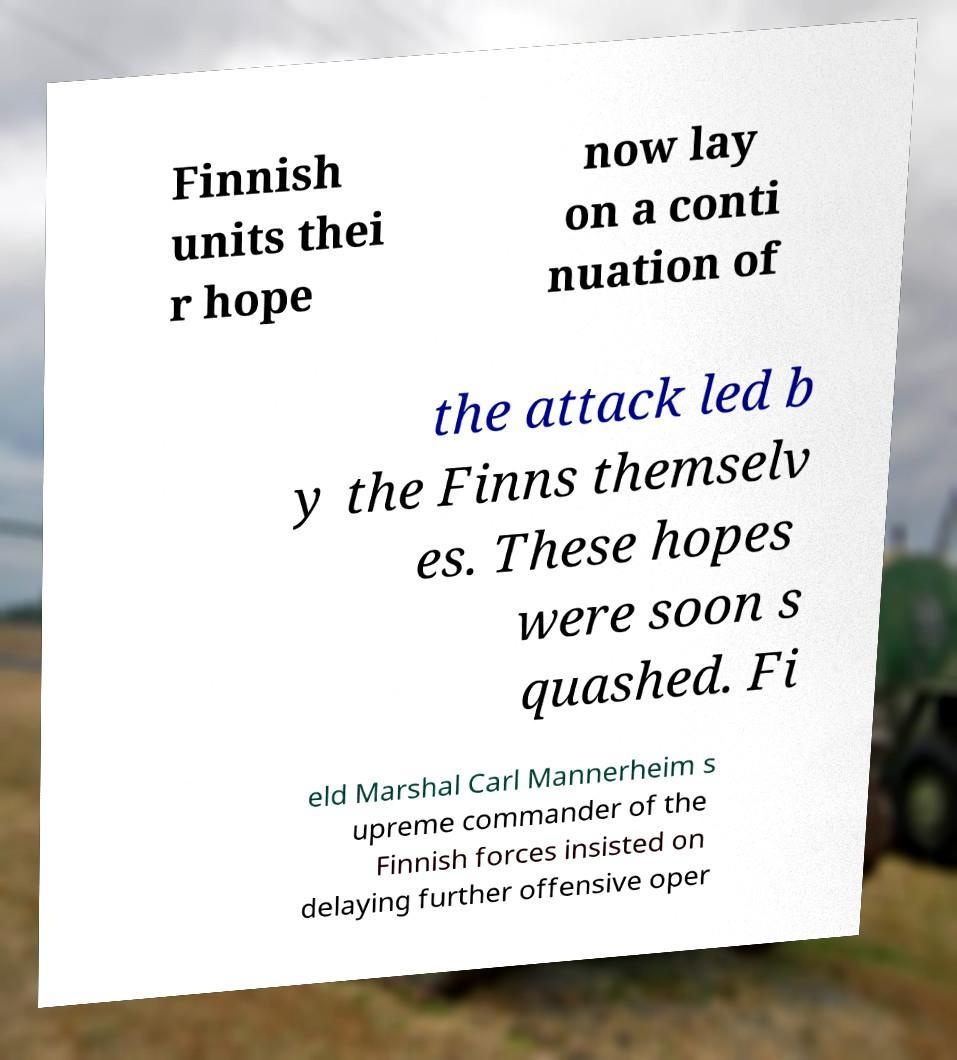Please read and relay the text visible in this image. What does it say? Finnish units thei r hope now lay on a conti nuation of the attack led b y the Finns themselv es. These hopes were soon s quashed. Fi eld Marshal Carl Mannerheim s upreme commander of the Finnish forces insisted on delaying further offensive oper 